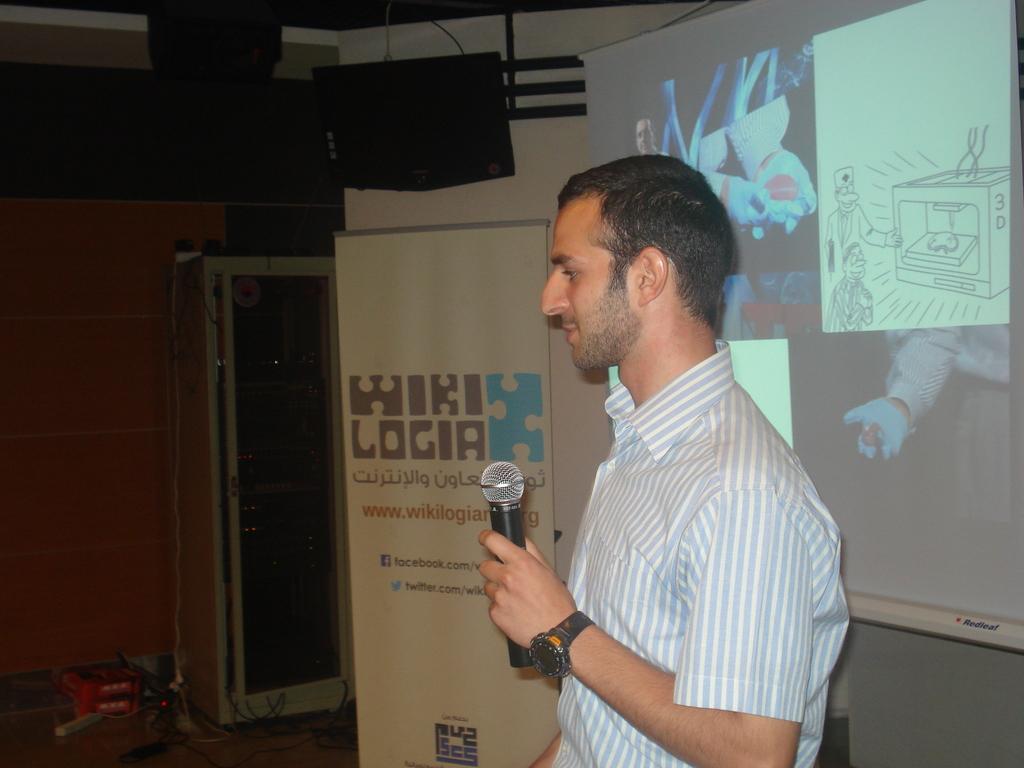Please provide a concise description of this image. In this picture there is a man who is wearing t-shirt and watch. He is holding a mic. Here we can see a banner, door and wooden wall. On the right we can see a projector screen. On the top there is a projector. On the bottom left corner we can see cotton boxes and books. 